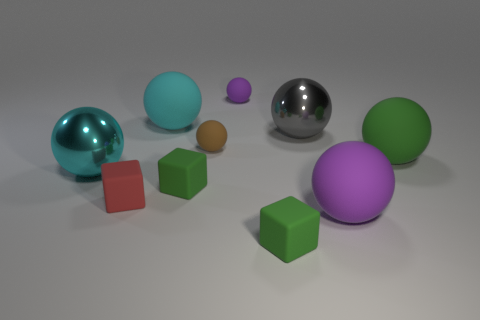Subtract all green rubber balls. How many balls are left? 6 Subtract all gray spheres. How many spheres are left? 6 Subtract all cubes. How many objects are left? 7 Subtract 2 cubes. How many cubes are left? 1 Subtract all cyan blocks. Subtract all red cylinders. How many blocks are left? 3 Subtract all green cylinders. How many yellow spheres are left? 0 Subtract all large cyan rubber objects. Subtract all brown objects. How many objects are left? 8 Add 6 big gray spheres. How many big gray spheres are left? 7 Add 8 small brown matte balls. How many small brown matte balls exist? 9 Subtract 0 blue cylinders. How many objects are left? 10 